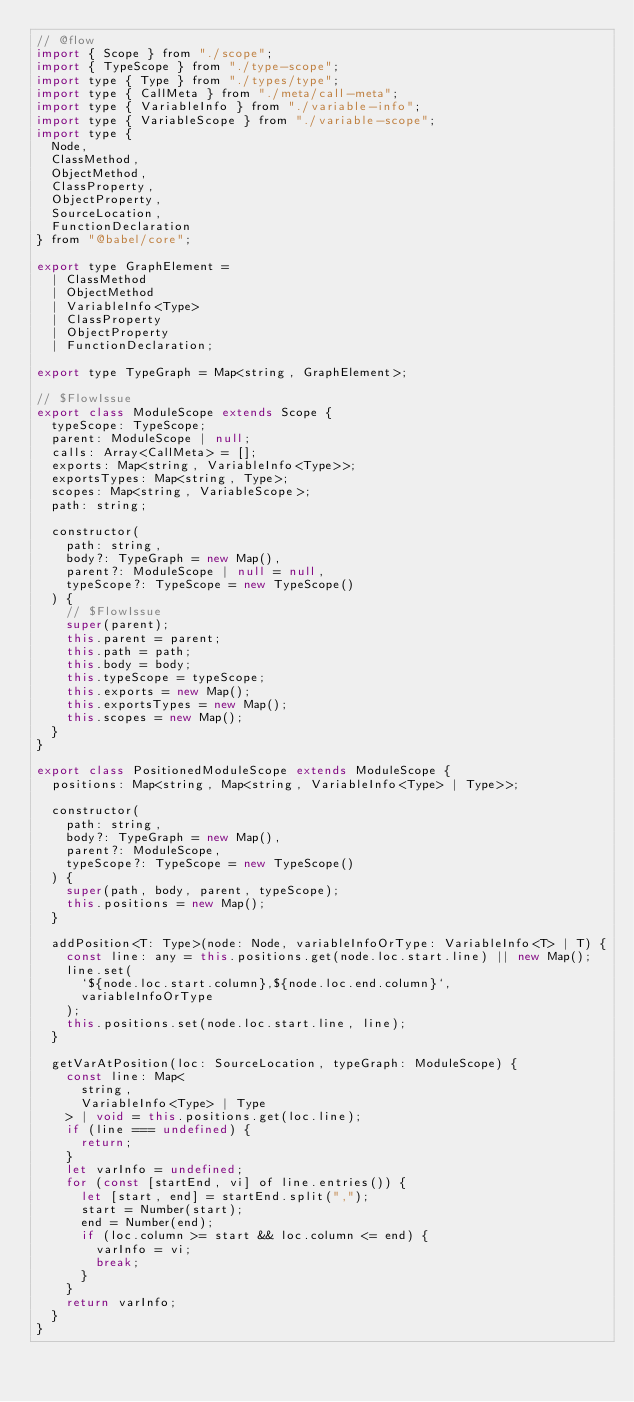<code> <loc_0><loc_0><loc_500><loc_500><_JavaScript_>// @flow
import { Scope } from "./scope";
import { TypeScope } from "./type-scope";
import type { Type } from "./types/type";
import type { CallMeta } from "./meta/call-meta";
import type { VariableInfo } from "./variable-info";
import type { VariableScope } from "./variable-scope";
import type {
  Node,
  ClassMethod,
  ObjectMethod,
  ClassProperty,
  ObjectProperty,
  SourceLocation,
  FunctionDeclaration
} from "@babel/core";

export type GraphElement =
  | ClassMethod
  | ObjectMethod
  | VariableInfo<Type>
  | ClassProperty
  | ObjectProperty
  | FunctionDeclaration;

export type TypeGraph = Map<string, GraphElement>;

// $FlowIssue
export class ModuleScope extends Scope {
  typeScope: TypeScope;
  parent: ModuleScope | null;
  calls: Array<CallMeta> = [];
  exports: Map<string, VariableInfo<Type>>;
  exportsTypes: Map<string, Type>;
  scopes: Map<string, VariableScope>;
  path: string;

  constructor(
    path: string,
    body?: TypeGraph = new Map(),
    parent?: ModuleScope | null = null,
    typeScope?: TypeScope = new TypeScope()
  ) {
    // $FlowIssue
    super(parent);
    this.parent = parent;
    this.path = path;
    this.body = body;
    this.typeScope = typeScope;
    this.exports = new Map();
    this.exportsTypes = new Map();
    this.scopes = new Map();
  }
}

export class PositionedModuleScope extends ModuleScope {
  positions: Map<string, Map<string, VariableInfo<Type> | Type>>;

  constructor(
    path: string,
    body?: TypeGraph = new Map(),
    parent?: ModuleScope,
    typeScope?: TypeScope = new TypeScope()
  ) {
    super(path, body, parent, typeScope);
    this.positions = new Map();
  }

  addPosition<T: Type>(node: Node, variableInfoOrType: VariableInfo<T> | T) {
    const line: any = this.positions.get(node.loc.start.line) || new Map();
    line.set(
      `${node.loc.start.column},${node.loc.end.column}`,
      variableInfoOrType
    );
    this.positions.set(node.loc.start.line, line);
  }

  getVarAtPosition(loc: SourceLocation, typeGraph: ModuleScope) {
    const line: Map<
      string,
      VariableInfo<Type> | Type
    > | void = this.positions.get(loc.line);
    if (line === undefined) {
      return;
    }
    let varInfo = undefined;
    for (const [startEnd, vi] of line.entries()) {
      let [start, end] = startEnd.split(",");
      start = Number(start);
      end = Number(end);
      if (loc.column >= start && loc.column <= end) {
        varInfo = vi;
        break;
      }
    }
    return varInfo;
  }
}
</code> 